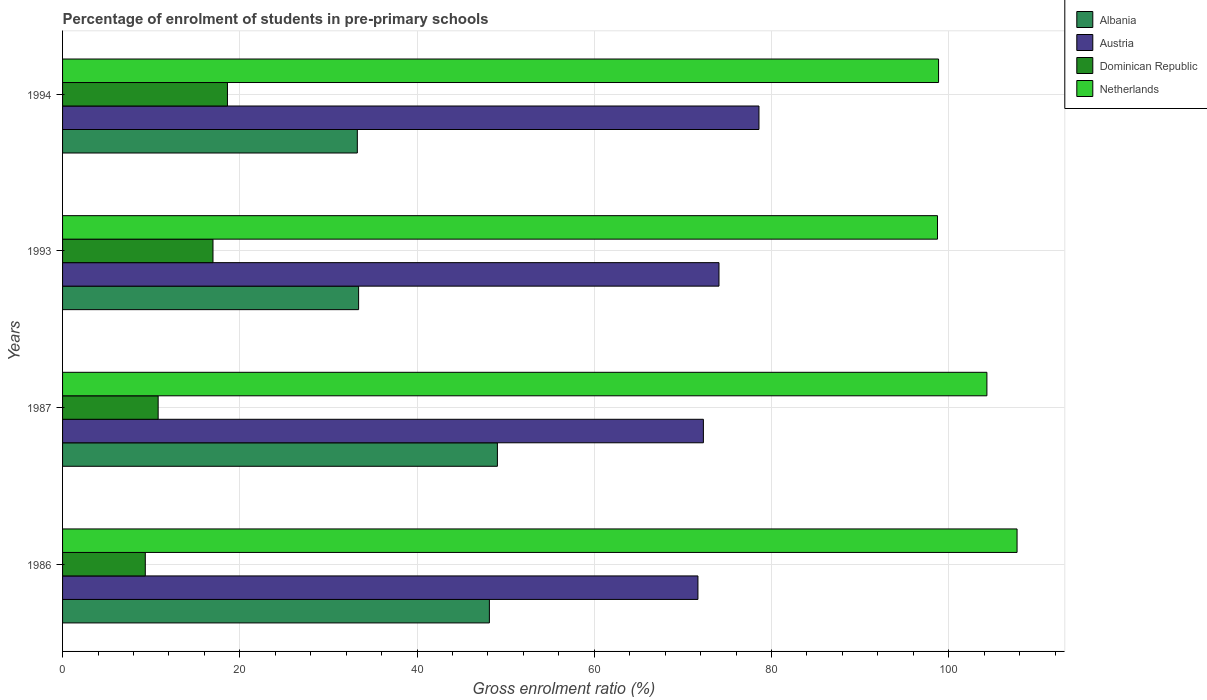How many groups of bars are there?
Keep it short and to the point. 4. How many bars are there on the 4th tick from the bottom?
Your answer should be very brief. 4. What is the label of the 3rd group of bars from the top?
Provide a short and direct response. 1987. In how many cases, is the number of bars for a given year not equal to the number of legend labels?
Provide a succinct answer. 0. What is the percentage of students enrolled in pre-primary schools in Netherlands in 1987?
Ensure brevity in your answer.  104.31. Across all years, what is the maximum percentage of students enrolled in pre-primary schools in Dominican Republic?
Offer a terse response. 18.61. Across all years, what is the minimum percentage of students enrolled in pre-primary schools in Dominican Republic?
Your answer should be very brief. 9.34. What is the total percentage of students enrolled in pre-primary schools in Netherlands in the graph?
Your answer should be very brief. 409.6. What is the difference between the percentage of students enrolled in pre-primary schools in Dominican Republic in 1993 and that in 1994?
Your answer should be compact. -1.63. What is the difference between the percentage of students enrolled in pre-primary schools in Netherlands in 1993 and the percentage of students enrolled in pre-primary schools in Albania in 1994?
Your answer should be very brief. 65.47. What is the average percentage of students enrolled in pre-primary schools in Albania per year?
Your response must be concise. 40.98. In the year 1994, what is the difference between the percentage of students enrolled in pre-primary schools in Netherlands and percentage of students enrolled in pre-primary schools in Albania?
Offer a very short reply. 65.59. What is the ratio of the percentage of students enrolled in pre-primary schools in Netherlands in 1987 to that in 1994?
Make the answer very short. 1.06. Is the percentage of students enrolled in pre-primary schools in Albania in 1993 less than that in 1994?
Make the answer very short. No. What is the difference between the highest and the second highest percentage of students enrolled in pre-primary schools in Netherlands?
Provide a succinct answer. 3.4. What is the difference between the highest and the lowest percentage of students enrolled in pre-primary schools in Dominican Republic?
Your response must be concise. 9.27. Is the sum of the percentage of students enrolled in pre-primary schools in Netherlands in 1986 and 1987 greater than the maximum percentage of students enrolled in pre-primary schools in Albania across all years?
Ensure brevity in your answer.  Yes. Is it the case that in every year, the sum of the percentage of students enrolled in pre-primary schools in Dominican Republic and percentage of students enrolled in pre-primary schools in Albania is greater than the sum of percentage of students enrolled in pre-primary schools in Netherlands and percentage of students enrolled in pre-primary schools in Austria?
Your answer should be very brief. No. What does the 2nd bar from the top in 1987 represents?
Your response must be concise. Dominican Republic. Is it the case that in every year, the sum of the percentage of students enrolled in pre-primary schools in Dominican Republic and percentage of students enrolled in pre-primary schools in Netherlands is greater than the percentage of students enrolled in pre-primary schools in Austria?
Ensure brevity in your answer.  Yes. How many bars are there?
Your answer should be very brief. 16. Does the graph contain any zero values?
Ensure brevity in your answer.  No. How many legend labels are there?
Offer a very short reply. 4. How are the legend labels stacked?
Your answer should be very brief. Vertical. What is the title of the graph?
Make the answer very short. Percentage of enrolment of students in pre-primary schools. What is the label or title of the Y-axis?
Provide a short and direct response. Years. What is the Gross enrolment ratio (%) of Albania in 1986?
Offer a very short reply. 48.17. What is the Gross enrolment ratio (%) of Austria in 1986?
Offer a very short reply. 71.7. What is the Gross enrolment ratio (%) of Dominican Republic in 1986?
Your response must be concise. 9.34. What is the Gross enrolment ratio (%) of Netherlands in 1986?
Offer a very short reply. 107.71. What is the Gross enrolment ratio (%) in Albania in 1987?
Provide a short and direct response. 49.07. What is the Gross enrolment ratio (%) of Austria in 1987?
Make the answer very short. 72.31. What is the Gross enrolment ratio (%) in Dominican Republic in 1987?
Offer a very short reply. 10.79. What is the Gross enrolment ratio (%) of Netherlands in 1987?
Offer a terse response. 104.31. What is the Gross enrolment ratio (%) in Albania in 1993?
Your response must be concise. 33.41. What is the Gross enrolment ratio (%) of Austria in 1993?
Offer a terse response. 74.07. What is the Gross enrolment ratio (%) in Dominican Republic in 1993?
Offer a very short reply. 16.97. What is the Gross enrolment ratio (%) of Netherlands in 1993?
Your response must be concise. 98.73. What is the Gross enrolment ratio (%) in Albania in 1994?
Your response must be concise. 33.26. What is the Gross enrolment ratio (%) in Austria in 1994?
Provide a succinct answer. 78.59. What is the Gross enrolment ratio (%) of Dominican Republic in 1994?
Give a very brief answer. 18.61. What is the Gross enrolment ratio (%) in Netherlands in 1994?
Provide a short and direct response. 98.85. Across all years, what is the maximum Gross enrolment ratio (%) of Albania?
Give a very brief answer. 49.07. Across all years, what is the maximum Gross enrolment ratio (%) in Austria?
Offer a very short reply. 78.59. Across all years, what is the maximum Gross enrolment ratio (%) in Dominican Republic?
Ensure brevity in your answer.  18.61. Across all years, what is the maximum Gross enrolment ratio (%) in Netherlands?
Provide a short and direct response. 107.71. Across all years, what is the minimum Gross enrolment ratio (%) in Albania?
Keep it short and to the point. 33.26. Across all years, what is the minimum Gross enrolment ratio (%) in Austria?
Give a very brief answer. 71.7. Across all years, what is the minimum Gross enrolment ratio (%) in Dominican Republic?
Offer a very short reply. 9.34. Across all years, what is the minimum Gross enrolment ratio (%) of Netherlands?
Your response must be concise. 98.73. What is the total Gross enrolment ratio (%) of Albania in the graph?
Offer a terse response. 163.91. What is the total Gross enrolment ratio (%) in Austria in the graph?
Your answer should be compact. 296.67. What is the total Gross enrolment ratio (%) of Dominican Republic in the graph?
Your answer should be very brief. 55.7. What is the total Gross enrolment ratio (%) in Netherlands in the graph?
Provide a succinct answer. 409.6. What is the difference between the Gross enrolment ratio (%) in Albania in 1986 and that in 1987?
Offer a very short reply. -0.9. What is the difference between the Gross enrolment ratio (%) of Austria in 1986 and that in 1987?
Keep it short and to the point. -0.61. What is the difference between the Gross enrolment ratio (%) of Dominican Republic in 1986 and that in 1987?
Provide a short and direct response. -1.45. What is the difference between the Gross enrolment ratio (%) of Netherlands in 1986 and that in 1987?
Your response must be concise. 3.4. What is the difference between the Gross enrolment ratio (%) in Albania in 1986 and that in 1993?
Offer a very short reply. 14.76. What is the difference between the Gross enrolment ratio (%) in Austria in 1986 and that in 1993?
Make the answer very short. -2.37. What is the difference between the Gross enrolment ratio (%) of Dominican Republic in 1986 and that in 1993?
Provide a short and direct response. -7.64. What is the difference between the Gross enrolment ratio (%) of Netherlands in 1986 and that in 1993?
Give a very brief answer. 8.98. What is the difference between the Gross enrolment ratio (%) of Albania in 1986 and that in 1994?
Your answer should be compact. 14.9. What is the difference between the Gross enrolment ratio (%) of Austria in 1986 and that in 1994?
Keep it short and to the point. -6.89. What is the difference between the Gross enrolment ratio (%) in Dominican Republic in 1986 and that in 1994?
Your answer should be compact. -9.27. What is the difference between the Gross enrolment ratio (%) in Netherlands in 1986 and that in 1994?
Make the answer very short. 8.86. What is the difference between the Gross enrolment ratio (%) of Albania in 1987 and that in 1993?
Provide a succinct answer. 15.66. What is the difference between the Gross enrolment ratio (%) in Austria in 1987 and that in 1993?
Provide a short and direct response. -1.76. What is the difference between the Gross enrolment ratio (%) of Dominican Republic in 1987 and that in 1993?
Make the answer very short. -6.19. What is the difference between the Gross enrolment ratio (%) in Netherlands in 1987 and that in 1993?
Your response must be concise. 5.58. What is the difference between the Gross enrolment ratio (%) of Albania in 1987 and that in 1994?
Give a very brief answer. 15.81. What is the difference between the Gross enrolment ratio (%) in Austria in 1987 and that in 1994?
Provide a succinct answer. -6.27. What is the difference between the Gross enrolment ratio (%) in Dominican Republic in 1987 and that in 1994?
Your response must be concise. -7.82. What is the difference between the Gross enrolment ratio (%) in Netherlands in 1987 and that in 1994?
Your answer should be very brief. 5.46. What is the difference between the Gross enrolment ratio (%) of Albania in 1993 and that in 1994?
Provide a succinct answer. 0.14. What is the difference between the Gross enrolment ratio (%) in Austria in 1993 and that in 1994?
Offer a terse response. -4.51. What is the difference between the Gross enrolment ratio (%) in Dominican Republic in 1993 and that in 1994?
Keep it short and to the point. -1.63. What is the difference between the Gross enrolment ratio (%) in Netherlands in 1993 and that in 1994?
Your answer should be very brief. -0.12. What is the difference between the Gross enrolment ratio (%) in Albania in 1986 and the Gross enrolment ratio (%) in Austria in 1987?
Your answer should be very brief. -24.15. What is the difference between the Gross enrolment ratio (%) in Albania in 1986 and the Gross enrolment ratio (%) in Dominican Republic in 1987?
Your answer should be very brief. 37.38. What is the difference between the Gross enrolment ratio (%) in Albania in 1986 and the Gross enrolment ratio (%) in Netherlands in 1987?
Make the answer very short. -56.14. What is the difference between the Gross enrolment ratio (%) of Austria in 1986 and the Gross enrolment ratio (%) of Dominican Republic in 1987?
Ensure brevity in your answer.  60.91. What is the difference between the Gross enrolment ratio (%) of Austria in 1986 and the Gross enrolment ratio (%) of Netherlands in 1987?
Make the answer very short. -32.61. What is the difference between the Gross enrolment ratio (%) of Dominican Republic in 1986 and the Gross enrolment ratio (%) of Netherlands in 1987?
Offer a terse response. -94.97. What is the difference between the Gross enrolment ratio (%) in Albania in 1986 and the Gross enrolment ratio (%) in Austria in 1993?
Your answer should be compact. -25.91. What is the difference between the Gross enrolment ratio (%) of Albania in 1986 and the Gross enrolment ratio (%) of Dominican Republic in 1993?
Keep it short and to the point. 31.19. What is the difference between the Gross enrolment ratio (%) in Albania in 1986 and the Gross enrolment ratio (%) in Netherlands in 1993?
Offer a terse response. -50.56. What is the difference between the Gross enrolment ratio (%) in Austria in 1986 and the Gross enrolment ratio (%) in Dominican Republic in 1993?
Offer a terse response. 54.73. What is the difference between the Gross enrolment ratio (%) in Austria in 1986 and the Gross enrolment ratio (%) in Netherlands in 1993?
Give a very brief answer. -27.03. What is the difference between the Gross enrolment ratio (%) of Dominican Republic in 1986 and the Gross enrolment ratio (%) of Netherlands in 1993?
Give a very brief answer. -89.39. What is the difference between the Gross enrolment ratio (%) of Albania in 1986 and the Gross enrolment ratio (%) of Austria in 1994?
Give a very brief answer. -30.42. What is the difference between the Gross enrolment ratio (%) in Albania in 1986 and the Gross enrolment ratio (%) in Dominican Republic in 1994?
Make the answer very short. 29.56. What is the difference between the Gross enrolment ratio (%) in Albania in 1986 and the Gross enrolment ratio (%) in Netherlands in 1994?
Your answer should be very brief. -50.69. What is the difference between the Gross enrolment ratio (%) of Austria in 1986 and the Gross enrolment ratio (%) of Dominican Republic in 1994?
Provide a succinct answer. 53.09. What is the difference between the Gross enrolment ratio (%) of Austria in 1986 and the Gross enrolment ratio (%) of Netherlands in 1994?
Your answer should be compact. -27.15. What is the difference between the Gross enrolment ratio (%) of Dominican Republic in 1986 and the Gross enrolment ratio (%) of Netherlands in 1994?
Provide a short and direct response. -89.52. What is the difference between the Gross enrolment ratio (%) in Albania in 1987 and the Gross enrolment ratio (%) in Austria in 1993?
Ensure brevity in your answer.  -25. What is the difference between the Gross enrolment ratio (%) in Albania in 1987 and the Gross enrolment ratio (%) in Dominican Republic in 1993?
Provide a short and direct response. 32.1. What is the difference between the Gross enrolment ratio (%) of Albania in 1987 and the Gross enrolment ratio (%) of Netherlands in 1993?
Offer a very short reply. -49.66. What is the difference between the Gross enrolment ratio (%) in Austria in 1987 and the Gross enrolment ratio (%) in Dominican Republic in 1993?
Keep it short and to the point. 55.34. What is the difference between the Gross enrolment ratio (%) in Austria in 1987 and the Gross enrolment ratio (%) in Netherlands in 1993?
Your response must be concise. -26.42. What is the difference between the Gross enrolment ratio (%) of Dominican Republic in 1987 and the Gross enrolment ratio (%) of Netherlands in 1993?
Offer a very short reply. -87.94. What is the difference between the Gross enrolment ratio (%) in Albania in 1987 and the Gross enrolment ratio (%) in Austria in 1994?
Your answer should be compact. -29.52. What is the difference between the Gross enrolment ratio (%) in Albania in 1987 and the Gross enrolment ratio (%) in Dominican Republic in 1994?
Make the answer very short. 30.46. What is the difference between the Gross enrolment ratio (%) in Albania in 1987 and the Gross enrolment ratio (%) in Netherlands in 1994?
Your answer should be very brief. -49.78. What is the difference between the Gross enrolment ratio (%) of Austria in 1987 and the Gross enrolment ratio (%) of Dominican Republic in 1994?
Keep it short and to the point. 53.71. What is the difference between the Gross enrolment ratio (%) in Austria in 1987 and the Gross enrolment ratio (%) in Netherlands in 1994?
Offer a terse response. -26.54. What is the difference between the Gross enrolment ratio (%) in Dominican Republic in 1987 and the Gross enrolment ratio (%) in Netherlands in 1994?
Give a very brief answer. -88.07. What is the difference between the Gross enrolment ratio (%) of Albania in 1993 and the Gross enrolment ratio (%) of Austria in 1994?
Provide a succinct answer. -45.18. What is the difference between the Gross enrolment ratio (%) in Albania in 1993 and the Gross enrolment ratio (%) in Dominican Republic in 1994?
Provide a short and direct response. 14.8. What is the difference between the Gross enrolment ratio (%) in Albania in 1993 and the Gross enrolment ratio (%) in Netherlands in 1994?
Offer a terse response. -65.44. What is the difference between the Gross enrolment ratio (%) of Austria in 1993 and the Gross enrolment ratio (%) of Dominican Republic in 1994?
Provide a succinct answer. 55.47. What is the difference between the Gross enrolment ratio (%) in Austria in 1993 and the Gross enrolment ratio (%) in Netherlands in 1994?
Your response must be concise. -24.78. What is the difference between the Gross enrolment ratio (%) of Dominican Republic in 1993 and the Gross enrolment ratio (%) of Netherlands in 1994?
Your answer should be very brief. -81.88. What is the average Gross enrolment ratio (%) in Albania per year?
Provide a short and direct response. 40.98. What is the average Gross enrolment ratio (%) in Austria per year?
Your answer should be compact. 74.17. What is the average Gross enrolment ratio (%) in Dominican Republic per year?
Make the answer very short. 13.93. What is the average Gross enrolment ratio (%) of Netherlands per year?
Make the answer very short. 102.4. In the year 1986, what is the difference between the Gross enrolment ratio (%) in Albania and Gross enrolment ratio (%) in Austria?
Offer a terse response. -23.53. In the year 1986, what is the difference between the Gross enrolment ratio (%) in Albania and Gross enrolment ratio (%) in Dominican Republic?
Offer a very short reply. 38.83. In the year 1986, what is the difference between the Gross enrolment ratio (%) of Albania and Gross enrolment ratio (%) of Netherlands?
Give a very brief answer. -59.55. In the year 1986, what is the difference between the Gross enrolment ratio (%) of Austria and Gross enrolment ratio (%) of Dominican Republic?
Keep it short and to the point. 62.36. In the year 1986, what is the difference between the Gross enrolment ratio (%) in Austria and Gross enrolment ratio (%) in Netherlands?
Provide a succinct answer. -36.01. In the year 1986, what is the difference between the Gross enrolment ratio (%) of Dominican Republic and Gross enrolment ratio (%) of Netherlands?
Provide a short and direct response. -98.38. In the year 1987, what is the difference between the Gross enrolment ratio (%) of Albania and Gross enrolment ratio (%) of Austria?
Ensure brevity in your answer.  -23.24. In the year 1987, what is the difference between the Gross enrolment ratio (%) of Albania and Gross enrolment ratio (%) of Dominican Republic?
Your response must be concise. 38.28. In the year 1987, what is the difference between the Gross enrolment ratio (%) in Albania and Gross enrolment ratio (%) in Netherlands?
Your answer should be very brief. -55.24. In the year 1987, what is the difference between the Gross enrolment ratio (%) of Austria and Gross enrolment ratio (%) of Dominican Republic?
Provide a short and direct response. 61.53. In the year 1987, what is the difference between the Gross enrolment ratio (%) of Austria and Gross enrolment ratio (%) of Netherlands?
Provide a succinct answer. -31.99. In the year 1987, what is the difference between the Gross enrolment ratio (%) in Dominican Republic and Gross enrolment ratio (%) in Netherlands?
Ensure brevity in your answer.  -93.52. In the year 1993, what is the difference between the Gross enrolment ratio (%) of Albania and Gross enrolment ratio (%) of Austria?
Ensure brevity in your answer.  -40.67. In the year 1993, what is the difference between the Gross enrolment ratio (%) of Albania and Gross enrolment ratio (%) of Dominican Republic?
Give a very brief answer. 16.43. In the year 1993, what is the difference between the Gross enrolment ratio (%) of Albania and Gross enrolment ratio (%) of Netherlands?
Your answer should be compact. -65.32. In the year 1993, what is the difference between the Gross enrolment ratio (%) in Austria and Gross enrolment ratio (%) in Dominican Republic?
Provide a short and direct response. 57.1. In the year 1993, what is the difference between the Gross enrolment ratio (%) of Austria and Gross enrolment ratio (%) of Netherlands?
Offer a very short reply. -24.66. In the year 1993, what is the difference between the Gross enrolment ratio (%) in Dominican Republic and Gross enrolment ratio (%) in Netherlands?
Offer a very short reply. -81.76. In the year 1994, what is the difference between the Gross enrolment ratio (%) in Albania and Gross enrolment ratio (%) in Austria?
Make the answer very short. -45.32. In the year 1994, what is the difference between the Gross enrolment ratio (%) in Albania and Gross enrolment ratio (%) in Dominican Republic?
Offer a terse response. 14.66. In the year 1994, what is the difference between the Gross enrolment ratio (%) of Albania and Gross enrolment ratio (%) of Netherlands?
Offer a very short reply. -65.59. In the year 1994, what is the difference between the Gross enrolment ratio (%) in Austria and Gross enrolment ratio (%) in Dominican Republic?
Keep it short and to the point. 59.98. In the year 1994, what is the difference between the Gross enrolment ratio (%) in Austria and Gross enrolment ratio (%) in Netherlands?
Make the answer very short. -20.27. In the year 1994, what is the difference between the Gross enrolment ratio (%) in Dominican Republic and Gross enrolment ratio (%) in Netherlands?
Your answer should be compact. -80.25. What is the ratio of the Gross enrolment ratio (%) of Albania in 1986 to that in 1987?
Provide a short and direct response. 0.98. What is the ratio of the Gross enrolment ratio (%) in Austria in 1986 to that in 1987?
Your answer should be very brief. 0.99. What is the ratio of the Gross enrolment ratio (%) of Dominican Republic in 1986 to that in 1987?
Keep it short and to the point. 0.87. What is the ratio of the Gross enrolment ratio (%) in Netherlands in 1986 to that in 1987?
Offer a terse response. 1.03. What is the ratio of the Gross enrolment ratio (%) in Albania in 1986 to that in 1993?
Offer a terse response. 1.44. What is the ratio of the Gross enrolment ratio (%) of Austria in 1986 to that in 1993?
Your answer should be very brief. 0.97. What is the ratio of the Gross enrolment ratio (%) of Dominican Republic in 1986 to that in 1993?
Your answer should be very brief. 0.55. What is the ratio of the Gross enrolment ratio (%) of Netherlands in 1986 to that in 1993?
Offer a terse response. 1.09. What is the ratio of the Gross enrolment ratio (%) of Albania in 1986 to that in 1994?
Provide a short and direct response. 1.45. What is the ratio of the Gross enrolment ratio (%) in Austria in 1986 to that in 1994?
Ensure brevity in your answer.  0.91. What is the ratio of the Gross enrolment ratio (%) of Dominican Republic in 1986 to that in 1994?
Make the answer very short. 0.5. What is the ratio of the Gross enrolment ratio (%) of Netherlands in 1986 to that in 1994?
Your response must be concise. 1.09. What is the ratio of the Gross enrolment ratio (%) in Albania in 1987 to that in 1993?
Your answer should be very brief. 1.47. What is the ratio of the Gross enrolment ratio (%) of Austria in 1987 to that in 1993?
Give a very brief answer. 0.98. What is the ratio of the Gross enrolment ratio (%) of Dominican Republic in 1987 to that in 1993?
Provide a succinct answer. 0.64. What is the ratio of the Gross enrolment ratio (%) in Netherlands in 1987 to that in 1993?
Offer a very short reply. 1.06. What is the ratio of the Gross enrolment ratio (%) in Albania in 1987 to that in 1994?
Provide a succinct answer. 1.48. What is the ratio of the Gross enrolment ratio (%) in Austria in 1987 to that in 1994?
Keep it short and to the point. 0.92. What is the ratio of the Gross enrolment ratio (%) in Dominican Republic in 1987 to that in 1994?
Make the answer very short. 0.58. What is the ratio of the Gross enrolment ratio (%) of Netherlands in 1987 to that in 1994?
Your answer should be very brief. 1.06. What is the ratio of the Gross enrolment ratio (%) of Austria in 1993 to that in 1994?
Your answer should be very brief. 0.94. What is the ratio of the Gross enrolment ratio (%) of Dominican Republic in 1993 to that in 1994?
Your answer should be compact. 0.91. What is the difference between the highest and the second highest Gross enrolment ratio (%) in Albania?
Offer a very short reply. 0.9. What is the difference between the highest and the second highest Gross enrolment ratio (%) in Austria?
Make the answer very short. 4.51. What is the difference between the highest and the second highest Gross enrolment ratio (%) of Dominican Republic?
Provide a short and direct response. 1.63. What is the difference between the highest and the second highest Gross enrolment ratio (%) of Netherlands?
Make the answer very short. 3.4. What is the difference between the highest and the lowest Gross enrolment ratio (%) in Albania?
Provide a succinct answer. 15.81. What is the difference between the highest and the lowest Gross enrolment ratio (%) of Austria?
Offer a very short reply. 6.89. What is the difference between the highest and the lowest Gross enrolment ratio (%) of Dominican Republic?
Your response must be concise. 9.27. What is the difference between the highest and the lowest Gross enrolment ratio (%) in Netherlands?
Offer a terse response. 8.98. 